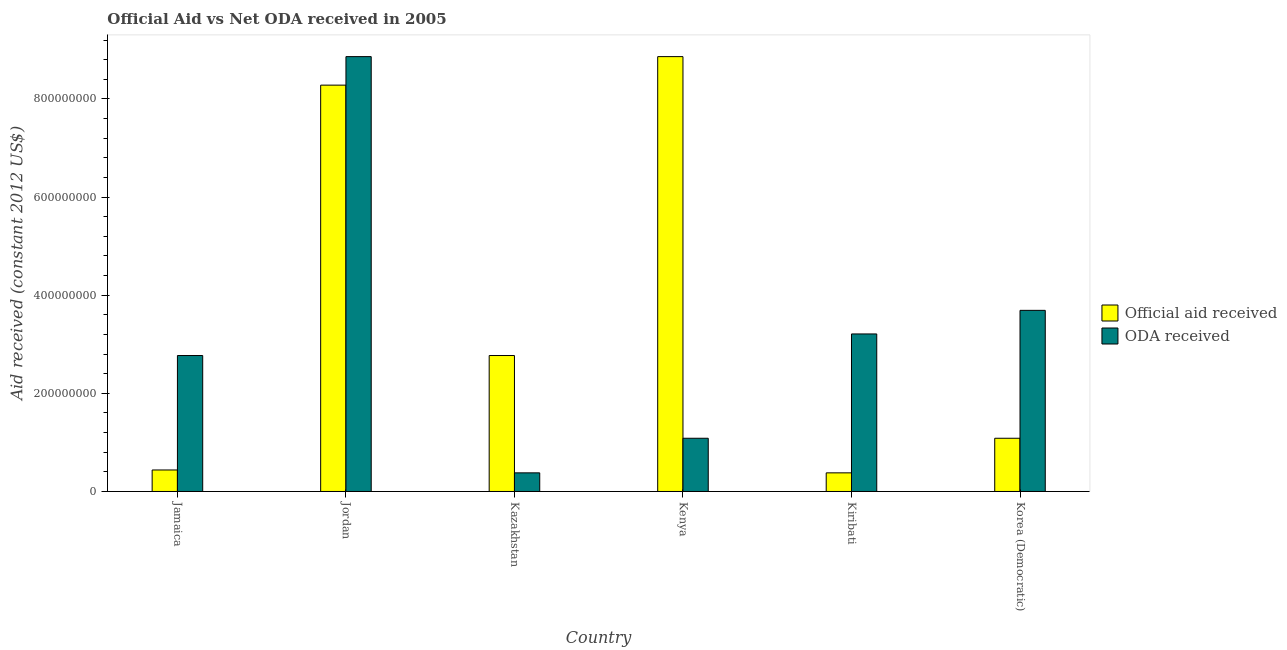How many groups of bars are there?
Provide a succinct answer. 6. Are the number of bars per tick equal to the number of legend labels?
Give a very brief answer. Yes. What is the label of the 5th group of bars from the left?
Make the answer very short. Kiribati. What is the oda received in Jordan?
Ensure brevity in your answer.  8.86e+08. Across all countries, what is the maximum official aid received?
Your response must be concise. 8.86e+08. Across all countries, what is the minimum oda received?
Your response must be concise. 3.80e+07. In which country was the official aid received maximum?
Your response must be concise. Kenya. In which country was the official aid received minimum?
Offer a very short reply. Kiribati. What is the total oda received in the graph?
Your answer should be compact. 2.00e+09. What is the difference between the official aid received in Jordan and that in Kiribati?
Your answer should be compact. 7.90e+08. What is the difference between the official aid received in Kiribati and the oda received in Jamaica?
Your answer should be very brief. -2.39e+08. What is the average oda received per country?
Your response must be concise. 3.33e+08. What is the difference between the official aid received and oda received in Kiribati?
Provide a short and direct response. -2.83e+08. What is the ratio of the official aid received in Jamaica to that in Kiribati?
Offer a terse response. 1.15. Is the oda received in Jordan less than that in Korea (Democratic)?
Your response must be concise. No. Is the difference between the oda received in Jamaica and Kiribati greater than the difference between the official aid received in Jamaica and Kiribati?
Your answer should be compact. No. What is the difference between the highest and the second highest official aid received?
Give a very brief answer. 5.81e+07. What is the difference between the highest and the lowest official aid received?
Make the answer very short. 8.48e+08. Is the sum of the official aid received in Kiribati and Korea (Democratic) greater than the maximum oda received across all countries?
Your answer should be compact. No. What does the 1st bar from the left in Jamaica represents?
Your answer should be compact. Official aid received. What does the 1st bar from the right in Kiribati represents?
Keep it short and to the point. ODA received. How many countries are there in the graph?
Offer a very short reply. 6. What is the difference between two consecutive major ticks on the Y-axis?
Offer a terse response. 2.00e+08. Are the values on the major ticks of Y-axis written in scientific E-notation?
Provide a short and direct response. No. Where does the legend appear in the graph?
Your answer should be very brief. Center right. How many legend labels are there?
Provide a short and direct response. 2. What is the title of the graph?
Give a very brief answer. Official Aid vs Net ODA received in 2005 . What is the label or title of the X-axis?
Offer a very short reply. Country. What is the label or title of the Y-axis?
Give a very brief answer. Aid received (constant 2012 US$). What is the Aid received (constant 2012 US$) in Official aid received in Jamaica?
Your response must be concise. 4.38e+07. What is the Aid received (constant 2012 US$) in ODA received in Jamaica?
Your answer should be compact. 2.77e+08. What is the Aid received (constant 2012 US$) in Official aid received in Jordan?
Offer a very short reply. 8.28e+08. What is the Aid received (constant 2012 US$) of ODA received in Jordan?
Your answer should be very brief. 8.86e+08. What is the Aid received (constant 2012 US$) in Official aid received in Kazakhstan?
Give a very brief answer. 2.77e+08. What is the Aid received (constant 2012 US$) of ODA received in Kazakhstan?
Give a very brief answer. 3.80e+07. What is the Aid received (constant 2012 US$) in Official aid received in Kenya?
Your response must be concise. 8.86e+08. What is the Aid received (constant 2012 US$) in ODA received in Kenya?
Give a very brief answer. 1.08e+08. What is the Aid received (constant 2012 US$) of Official aid received in Kiribati?
Provide a short and direct response. 3.80e+07. What is the Aid received (constant 2012 US$) in ODA received in Kiribati?
Keep it short and to the point. 3.21e+08. What is the Aid received (constant 2012 US$) of Official aid received in Korea (Democratic)?
Your answer should be compact. 1.08e+08. What is the Aid received (constant 2012 US$) of ODA received in Korea (Democratic)?
Your response must be concise. 3.69e+08. Across all countries, what is the maximum Aid received (constant 2012 US$) in Official aid received?
Provide a succinct answer. 8.86e+08. Across all countries, what is the maximum Aid received (constant 2012 US$) of ODA received?
Offer a very short reply. 8.86e+08. Across all countries, what is the minimum Aid received (constant 2012 US$) of Official aid received?
Make the answer very short. 3.80e+07. Across all countries, what is the minimum Aid received (constant 2012 US$) in ODA received?
Your response must be concise. 3.80e+07. What is the total Aid received (constant 2012 US$) in Official aid received in the graph?
Provide a short and direct response. 2.18e+09. What is the total Aid received (constant 2012 US$) of ODA received in the graph?
Offer a terse response. 2.00e+09. What is the difference between the Aid received (constant 2012 US$) in Official aid received in Jamaica and that in Jordan?
Offer a terse response. -7.84e+08. What is the difference between the Aid received (constant 2012 US$) of ODA received in Jamaica and that in Jordan?
Give a very brief answer. -6.09e+08. What is the difference between the Aid received (constant 2012 US$) of Official aid received in Jamaica and that in Kazakhstan?
Your answer should be compact. -2.33e+08. What is the difference between the Aid received (constant 2012 US$) of ODA received in Jamaica and that in Kazakhstan?
Make the answer very short. 2.39e+08. What is the difference between the Aid received (constant 2012 US$) of Official aid received in Jamaica and that in Kenya?
Your answer should be compact. -8.42e+08. What is the difference between the Aid received (constant 2012 US$) in ODA received in Jamaica and that in Kenya?
Your answer should be compact. 1.69e+08. What is the difference between the Aid received (constant 2012 US$) of Official aid received in Jamaica and that in Kiribati?
Your response must be concise. 5.85e+06. What is the difference between the Aid received (constant 2012 US$) of ODA received in Jamaica and that in Kiribati?
Offer a very short reply. -4.40e+07. What is the difference between the Aid received (constant 2012 US$) of Official aid received in Jamaica and that in Korea (Democratic)?
Offer a very short reply. -6.46e+07. What is the difference between the Aid received (constant 2012 US$) of ODA received in Jamaica and that in Korea (Democratic)?
Ensure brevity in your answer.  -9.21e+07. What is the difference between the Aid received (constant 2012 US$) of Official aid received in Jordan and that in Kazakhstan?
Make the answer very short. 5.51e+08. What is the difference between the Aid received (constant 2012 US$) in ODA received in Jordan and that in Kazakhstan?
Provide a short and direct response. 8.48e+08. What is the difference between the Aid received (constant 2012 US$) of Official aid received in Jordan and that in Kenya?
Make the answer very short. -5.81e+07. What is the difference between the Aid received (constant 2012 US$) in ODA received in Jordan and that in Kenya?
Your answer should be very brief. 7.78e+08. What is the difference between the Aid received (constant 2012 US$) in Official aid received in Jordan and that in Kiribati?
Your answer should be compact. 7.90e+08. What is the difference between the Aid received (constant 2012 US$) in ODA received in Jordan and that in Kiribati?
Keep it short and to the point. 5.65e+08. What is the difference between the Aid received (constant 2012 US$) in Official aid received in Jordan and that in Korea (Democratic)?
Your answer should be very brief. 7.20e+08. What is the difference between the Aid received (constant 2012 US$) in ODA received in Jordan and that in Korea (Democratic)?
Your answer should be compact. 5.17e+08. What is the difference between the Aid received (constant 2012 US$) of Official aid received in Kazakhstan and that in Kenya?
Your answer should be very brief. -6.09e+08. What is the difference between the Aid received (constant 2012 US$) of ODA received in Kazakhstan and that in Kenya?
Give a very brief answer. -7.05e+07. What is the difference between the Aid received (constant 2012 US$) of Official aid received in Kazakhstan and that in Kiribati?
Your answer should be compact. 2.39e+08. What is the difference between the Aid received (constant 2012 US$) in ODA received in Kazakhstan and that in Kiribati?
Make the answer very short. -2.83e+08. What is the difference between the Aid received (constant 2012 US$) in Official aid received in Kazakhstan and that in Korea (Democratic)?
Give a very brief answer. 1.69e+08. What is the difference between the Aid received (constant 2012 US$) in ODA received in Kazakhstan and that in Korea (Democratic)?
Offer a very short reply. -3.31e+08. What is the difference between the Aid received (constant 2012 US$) of Official aid received in Kenya and that in Kiribati?
Give a very brief answer. 8.48e+08. What is the difference between the Aid received (constant 2012 US$) in ODA received in Kenya and that in Kiribati?
Your answer should be compact. -2.13e+08. What is the difference between the Aid received (constant 2012 US$) of Official aid received in Kenya and that in Korea (Democratic)?
Make the answer very short. 7.78e+08. What is the difference between the Aid received (constant 2012 US$) in ODA received in Kenya and that in Korea (Democratic)?
Keep it short and to the point. -2.61e+08. What is the difference between the Aid received (constant 2012 US$) of Official aid received in Kiribati and that in Korea (Democratic)?
Your answer should be compact. -7.05e+07. What is the difference between the Aid received (constant 2012 US$) of ODA received in Kiribati and that in Korea (Democratic)?
Provide a succinct answer. -4.81e+07. What is the difference between the Aid received (constant 2012 US$) in Official aid received in Jamaica and the Aid received (constant 2012 US$) in ODA received in Jordan?
Offer a terse response. -8.42e+08. What is the difference between the Aid received (constant 2012 US$) in Official aid received in Jamaica and the Aid received (constant 2012 US$) in ODA received in Kazakhstan?
Ensure brevity in your answer.  5.85e+06. What is the difference between the Aid received (constant 2012 US$) of Official aid received in Jamaica and the Aid received (constant 2012 US$) of ODA received in Kenya?
Provide a short and direct response. -6.46e+07. What is the difference between the Aid received (constant 2012 US$) in Official aid received in Jamaica and the Aid received (constant 2012 US$) in ODA received in Kiribati?
Your answer should be very brief. -2.77e+08. What is the difference between the Aid received (constant 2012 US$) in Official aid received in Jamaica and the Aid received (constant 2012 US$) in ODA received in Korea (Democratic)?
Make the answer very short. -3.25e+08. What is the difference between the Aid received (constant 2012 US$) of Official aid received in Jordan and the Aid received (constant 2012 US$) of ODA received in Kazakhstan?
Provide a succinct answer. 7.90e+08. What is the difference between the Aid received (constant 2012 US$) in Official aid received in Jordan and the Aid received (constant 2012 US$) in ODA received in Kenya?
Ensure brevity in your answer.  7.20e+08. What is the difference between the Aid received (constant 2012 US$) in Official aid received in Jordan and the Aid received (constant 2012 US$) in ODA received in Kiribati?
Provide a succinct answer. 5.07e+08. What is the difference between the Aid received (constant 2012 US$) in Official aid received in Jordan and the Aid received (constant 2012 US$) in ODA received in Korea (Democratic)?
Your response must be concise. 4.59e+08. What is the difference between the Aid received (constant 2012 US$) of Official aid received in Kazakhstan and the Aid received (constant 2012 US$) of ODA received in Kenya?
Offer a very short reply. 1.69e+08. What is the difference between the Aid received (constant 2012 US$) of Official aid received in Kazakhstan and the Aid received (constant 2012 US$) of ODA received in Kiribati?
Provide a short and direct response. -4.40e+07. What is the difference between the Aid received (constant 2012 US$) of Official aid received in Kazakhstan and the Aid received (constant 2012 US$) of ODA received in Korea (Democratic)?
Make the answer very short. -9.21e+07. What is the difference between the Aid received (constant 2012 US$) of Official aid received in Kenya and the Aid received (constant 2012 US$) of ODA received in Kiribati?
Provide a short and direct response. 5.65e+08. What is the difference between the Aid received (constant 2012 US$) of Official aid received in Kenya and the Aid received (constant 2012 US$) of ODA received in Korea (Democratic)?
Make the answer very short. 5.17e+08. What is the difference between the Aid received (constant 2012 US$) in Official aid received in Kiribati and the Aid received (constant 2012 US$) in ODA received in Korea (Democratic)?
Offer a very short reply. -3.31e+08. What is the average Aid received (constant 2012 US$) in Official aid received per country?
Make the answer very short. 3.64e+08. What is the average Aid received (constant 2012 US$) of ODA received per country?
Make the answer very short. 3.33e+08. What is the difference between the Aid received (constant 2012 US$) of Official aid received and Aid received (constant 2012 US$) of ODA received in Jamaica?
Provide a short and direct response. -2.33e+08. What is the difference between the Aid received (constant 2012 US$) of Official aid received and Aid received (constant 2012 US$) of ODA received in Jordan?
Offer a terse response. -5.81e+07. What is the difference between the Aid received (constant 2012 US$) in Official aid received and Aid received (constant 2012 US$) in ODA received in Kazakhstan?
Keep it short and to the point. 2.39e+08. What is the difference between the Aid received (constant 2012 US$) of Official aid received and Aid received (constant 2012 US$) of ODA received in Kenya?
Ensure brevity in your answer.  7.78e+08. What is the difference between the Aid received (constant 2012 US$) of Official aid received and Aid received (constant 2012 US$) of ODA received in Kiribati?
Your response must be concise. -2.83e+08. What is the difference between the Aid received (constant 2012 US$) of Official aid received and Aid received (constant 2012 US$) of ODA received in Korea (Democratic)?
Ensure brevity in your answer.  -2.61e+08. What is the ratio of the Aid received (constant 2012 US$) in Official aid received in Jamaica to that in Jordan?
Your answer should be compact. 0.05. What is the ratio of the Aid received (constant 2012 US$) of ODA received in Jamaica to that in Jordan?
Make the answer very short. 0.31. What is the ratio of the Aid received (constant 2012 US$) in Official aid received in Jamaica to that in Kazakhstan?
Offer a terse response. 0.16. What is the ratio of the Aid received (constant 2012 US$) in ODA received in Jamaica to that in Kazakhstan?
Your answer should be compact. 7.3. What is the ratio of the Aid received (constant 2012 US$) of Official aid received in Jamaica to that in Kenya?
Your answer should be very brief. 0.05. What is the ratio of the Aid received (constant 2012 US$) of ODA received in Jamaica to that in Kenya?
Provide a succinct answer. 2.55. What is the ratio of the Aid received (constant 2012 US$) of Official aid received in Jamaica to that in Kiribati?
Your response must be concise. 1.15. What is the ratio of the Aid received (constant 2012 US$) in ODA received in Jamaica to that in Kiribati?
Make the answer very short. 0.86. What is the ratio of the Aid received (constant 2012 US$) of Official aid received in Jamaica to that in Korea (Democratic)?
Make the answer very short. 0.4. What is the ratio of the Aid received (constant 2012 US$) of ODA received in Jamaica to that in Korea (Democratic)?
Provide a succinct answer. 0.75. What is the ratio of the Aid received (constant 2012 US$) in Official aid received in Jordan to that in Kazakhstan?
Your answer should be compact. 2.99. What is the ratio of the Aid received (constant 2012 US$) of ODA received in Jordan to that in Kazakhstan?
Offer a terse response. 23.35. What is the ratio of the Aid received (constant 2012 US$) in Official aid received in Jordan to that in Kenya?
Ensure brevity in your answer.  0.93. What is the ratio of the Aid received (constant 2012 US$) of ODA received in Jordan to that in Kenya?
Provide a succinct answer. 8.17. What is the ratio of the Aid received (constant 2012 US$) of Official aid received in Jordan to that in Kiribati?
Your answer should be compact. 21.82. What is the ratio of the Aid received (constant 2012 US$) of ODA received in Jordan to that in Kiribati?
Your answer should be very brief. 2.76. What is the ratio of the Aid received (constant 2012 US$) in Official aid received in Jordan to that in Korea (Democratic)?
Your response must be concise. 7.64. What is the ratio of the Aid received (constant 2012 US$) of ODA received in Jordan to that in Korea (Democratic)?
Your response must be concise. 2.4. What is the ratio of the Aid received (constant 2012 US$) in Official aid received in Kazakhstan to that in Kenya?
Give a very brief answer. 0.31. What is the ratio of the Aid received (constant 2012 US$) in Official aid received in Kazakhstan to that in Kiribati?
Keep it short and to the point. 7.3. What is the ratio of the Aid received (constant 2012 US$) in ODA received in Kazakhstan to that in Kiribati?
Your response must be concise. 0.12. What is the ratio of the Aid received (constant 2012 US$) of Official aid received in Kazakhstan to that in Korea (Democratic)?
Give a very brief answer. 2.55. What is the ratio of the Aid received (constant 2012 US$) in ODA received in Kazakhstan to that in Korea (Democratic)?
Provide a short and direct response. 0.1. What is the ratio of the Aid received (constant 2012 US$) of Official aid received in Kenya to that in Kiribati?
Provide a short and direct response. 23.35. What is the ratio of the Aid received (constant 2012 US$) of ODA received in Kenya to that in Kiribati?
Ensure brevity in your answer.  0.34. What is the ratio of the Aid received (constant 2012 US$) of Official aid received in Kenya to that in Korea (Democratic)?
Make the answer very short. 8.17. What is the ratio of the Aid received (constant 2012 US$) in ODA received in Kenya to that in Korea (Democratic)?
Provide a succinct answer. 0.29. What is the ratio of the Aid received (constant 2012 US$) of Official aid received in Kiribati to that in Korea (Democratic)?
Ensure brevity in your answer.  0.35. What is the ratio of the Aid received (constant 2012 US$) of ODA received in Kiribati to that in Korea (Democratic)?
Your answer should be compact. 0.87. What is the difference between the highest and the second highest Aid received (constant 2012 US$) in Official aid received?
Keep it short and to the point. 5.81e+07. What is the difference between the highest and the second highest Aid received (constant 2012 US$) in ODA received?
Provide a succinct answer. 5.17e+08. What is the difference between the highest and the lowest Aid received (constant 2012 US$) of Official aid received?
Offer a very short reply. 8.48e+08. What is the difference between the highest and the lowest Aid received (constant 2012 US$) of ODA received?
Keep it short and to the point. 8.48e+08. 